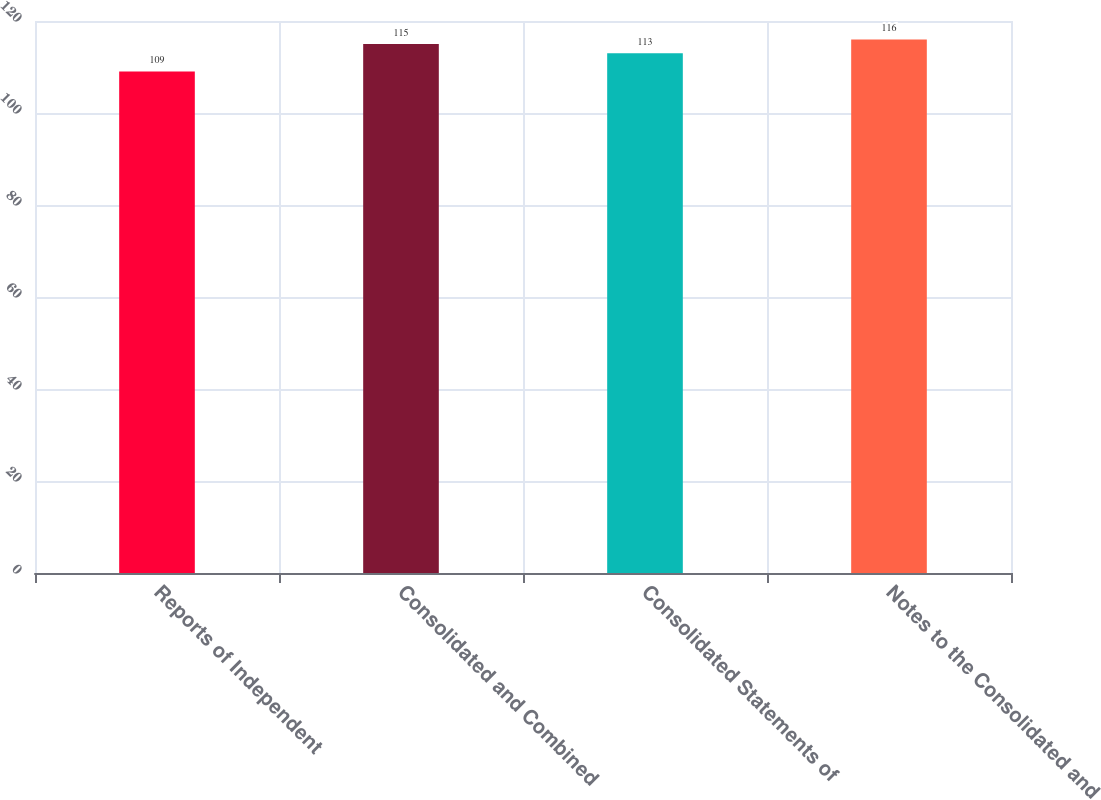Convert chart to OTSL. <chart><loc_0><loc_0><loc_500><loc_500><bar_chart><fcel>Reports of Independent<fcel>Consolidated and Combined<fcel>Consolidated Statements of<fcel>Notes to the Consolidated and<nl><fcel>109<fcel>115<fcel>113<fcel>116<nl></chart> 